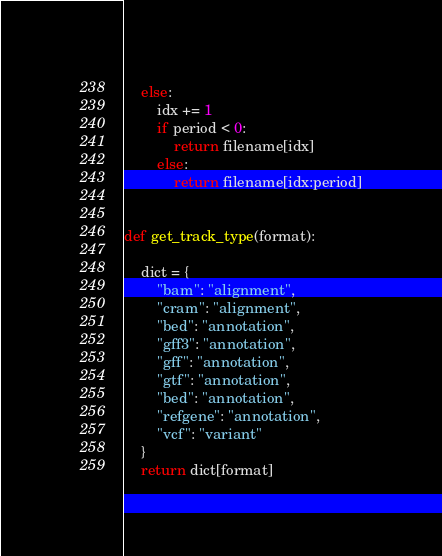<code> <loc_0><loc_0><loc_500><loc_500><_Python_>    else:
        idx += 1
        if period < 0:
            return filename[idx]
        else:
            return filename[idx:period]


def get_track_type(format):

    dict = {
        "bam": "alignment",
        "cram": "alignment",
        "bed": "annotation",
        "gff3": "annotation",
        "gff": "annotation",
        "gtf": "annotation",
        "bed": "annotation",
        "refgene": "annotation",
        "vcf": "variant"
    }
    return dict[format]
</code> 